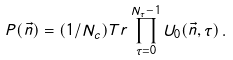Convert formula to latex. <formula><loc_0><loc_0><loc_500><loc_500>P ( \vec { n } ) = ( 1 / N _ { c } ) T r \prod ^ { N _ { \tau } - 1 } _ { \tau = 0 } U _ { 0 } ( \vec { n } , \tau ) \, .</formula> 